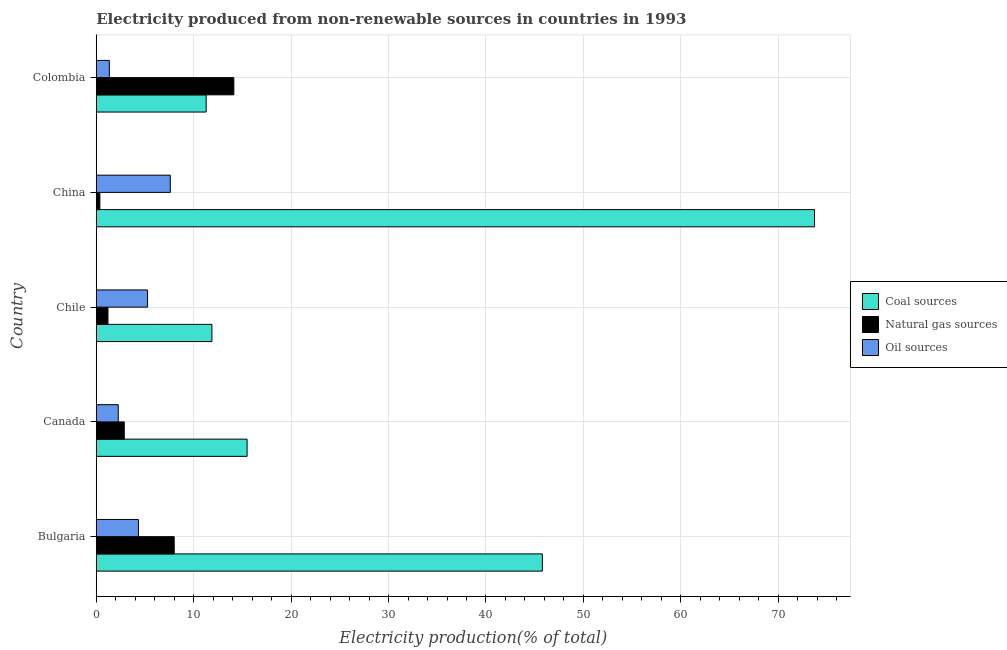How many different coloured bars are there?
Offer a terse response. 3. How many groups of bars are there?
Offer a very short reply. 5. Are the number of bars per tick equal to the number of legend labels?
Keep it short and to the point. Yes. What is the label of the 3rd group of bars from the top?
Give a very brief answer. Chile. What is the percentage of electricity produced by natural gas in Bulgaria?
Your answer should be very brief. 8. Across all countries, what is the maximum percentage of electricity produced by natural gas?
Your answer should be compact. 14.12. Across all countries, what is the minimum percentage of electricity produced by oil sources?
Provide a short and direct response. 1.34. In which country was the percentage of electricity produced by natural gas maximum?
Offer a very short reply. Colombia. In which country was the percentage of electricity produced by coal minimum?
Your answer should be compact. Colombia. What is the total percentage of electricity produced by coal in the graph?
Provide a short and direct response. 158.15. What is the difference between the percentage of electricity produced by natural gas in Canada and that in China?
Provide a short and direct response. 2.5. What is the difference between the percentage of electricity produced by natural gas in Canada and the percentage of electricity produced by oil sources in Chile?
Offer a very short reply. -2.39. What is the average percentage of electricity produced by natural gas per country?
Keep it short and to the point. 5.31. What is the difference between the percentage of electricity produced by coal and percentage of electricity produced by natural gas in China?
Provide a succinct answer. 73.35. What is the ratio of the percentage of electricity produced by coal in Canada to that in China?
Give a very brief answer. 0.21. Is the percentage of electricity produced by natural gas in Chile less than that in China?
Make the answer very short. No. What is the difference between the highest and the second highest percentage of electricity produced by natural gas?
Make the answer very short. 6.12. What is the difference between the highest and the lowest percentage of electricity produced by coal?
Keep it short and to the point. 62.44. In how many countries, is the percentage of electricity produced by coal greater than the average percentage of electricity produced by coal taken over all countries?
Ensure brevity in your answer.  2. What does the 1st bar from the top in Bulgaria represents?
Offer a terse response. Oil sources. What does the 1st bar from the bottom in Colombia represents?
Provide a succinct answer. Coal sources. Is it the case that in every country, the sum of the percentage of electricity produced by coal and percentage of electricity produced by natural gas is greater than the percentage of electricity produced by oil sources?
Provide a succinct answer. Yes. Where does the legend appear in the graph?
Keep it short and to the point. Center right. How many legend labels are there?
Offer a very short reply. 3. How are the legend labels stacked?
Provide a short and direct response. Vertical. What is the title of the graph?
Make the answer very short. Electricity produced from non-renewable sources in countries in 1993. Does "Taxes on income" appear as one of the legend labels in the graph?
Offer a very short reply. No. What is the Electricity production(% of total) of Coal sources in Bulgaria?
Your response must be concise. 45.79. What is the Electricity production(% of total) of Natural gas sources in Bulgaria?
Provide a short and direct response. 8. What is the Electricity production(% of total) of Oil sources in Bulgaria?
Make the answer very short. 4.33. What is the Electricity production(% of total) in Coal sources in Canada?
Ensure brevity in your answer.  15.48. What is the Electricity production(% of total) of Natural gas sources in Canada?
Offer a very short reply. 2.88. What is the Electricity production(% of total) of Oil sources in Canada?
Offer a very short reply. 2.26. What is the Electricity production(% of total) of Coal sources in Chile?
Offer a very short reply. 11.87. What is the Electricity production(% of total) in Natural gas sources in Chile?
Keep it short and to the point. 1.2. What is the Electricity production(% of total) of Oil sources in Chile?
Your answer should be very brief. 5.27. What is the Electricity production(% of total) in Coal sources in China?
Keep it short and to the point. 73.73. What is the Electricity production(% of total) in Natural gas sources in China?
Offer a terse response. 0.37. What is the Electricity production(% of total) in Oil sources in China?
Provide a short and direct response. 7.6. What is the Electricity production(% of total) in Coal sources in Colombia?
Offer a terse response. 11.28. What is the Electricity production(% of total) in Natural gas sources in Colombia?
Provide a short and direct response. 14.12. What is the Electricity production(% of total) of Oil sources in Colombia?
Give a very brief answer. 1.34. Across all countries, what is the maximum Electricity production(% of total) of Coal sources?
Your answer should be very brief. 73.73. Across all countries, what is the maximum Electricity production(% of total) in Natural gas sources?
Your answer should be very brief. 14.12. Across all countries, what is the maximum Electricity production(% of total) of Oil sources?
Your response must be concise. 7.6. Across all countries, what is the minimum Electricity production(% of total) of Coal sources?
Ensure brevity in your answer.  11.28. Across all countries, what is the minimum Electricity production(% of total) in Natural gas sources?
Give a very brief answer. 0.37. Across all countries, what is the minimum Electricity production(% of total) in Oil sources?
Give a very brief answer. 1.34. What is the total Electricity production(% of total) of Coal sources in the graph?
Your answer should be very brief. 158.15. What is the total Electricity production(% of total) of Natural gas sources in the graph?
Your response must be concise. 26.57. What is the total Electricity production(% of total) in Oil sources in the graph?
Offer a terse response. 20.79. What is the difference between the Electricity production(% of total) in Coal sources in Bulgaria and that in Canada?
Your answer should be very brief. 30.31. What is the difference between the Electricity production(% of total) in Natural gas sources in Bulgaria and that in Canada?
Provide a short and direct response. 5.13. What is the difference between the Electricity production(% of total) of Oil sources in Bulgaria and that in Canada?
Your response must be concise. 2.07. What is the difference between the Electricity production(% of total) in Coal sources in Bulgaria and that in Chile?
Give a very brief answer. 33.92. What is the difference between the Electricity production(% of total) in Natural gas sources in Bulgaria and that in Chile?
Your answer should be compact. 6.8. What is the difference between the Electricity production(% of total) of Oil sources in Bulgaria and that in Chile?
Give a very brief answer. -0.94. What is the difference between the Electricity production(% of total) of Coal sources in Bulgaria and that in China?
Your answer should be very brief. -27.94. What is the difference between the Electricity production(% of total) in Natural gas sources in Bulgaria and that in China?
Offer a terse response. 7.63. What is the difference between the Electricity production(% of total) in Oil sources in Bulgaria and that in China?
Provide a succinct answer. -3.27. What is the difference between the Electricity production(% of total) in Coal sources in Bulgaria and that in Colombia?
Provide a succinct answer. 34.51. What is the difference between the Electricity production(% of total) in Natural gas sources in Bulgaria and that in Colombia?
Provide a short and direct response. -6.12. What is the difference between the Electricity production(% of total) in Oil sources in Bulgaria and that in Colombia?
Offer a terse response. 2.98. What is the difference between the Electricity production(% of total) in Coal sources in Canada and that in Chile?
Make the answer very short. 3.61. What is the difference between the Electricity production(% of total) in Natural gas sources in Canada and that in Chile?
Your answer should be compact. 1.68. What is the difference between the Electricity production(% of total) in Oil sources in Canada and that in Chile?
Offer a terse response. -3.01. What is the difference between the Electricity production(% of total) of Coal sources in Canada and that in China?
Make the answer very short. -58.24. What is the difference between the Electricity production(% of total) of Natural gas sources in Canada and that in China?
Your answer should be very brief. 2.5. What is the difference between the Electricity production(% of total) of Oil sources in Canada and that in China?
Your answer should be compact. -5.34. What is the difference between the Electricity production(% of total) in Coal sources in Canada and that in Colombia?
Your answer should be compact. 4.2. What is the difference between the Electricity production(% of total) in Natural gas sources in Canada and that in Colombia?
Your answer should be very brief. -11.25. What is the difference between the Electricity production(% of total) of Oil sources in Canada and that in Colombia?
Keep it short and to the point. 0.91. What is the difference between the Electricity production(% of total) in Coal sources in Chile and that in China?
Provide a succinct answer. -61.86. What is the difference between the Electricity production(% of total) of Natural gas sources in Chile and that in China?
Give a very brief answer. 0.83. What is the difference between the Electricity production(% of total) in Oil sources in Chile and that in China?
Offer a terse response. -2.33. What is the difference between the Electricity production(% of total) of Coal sources in Chile and that in Colombia?
Keep it short and to the point. 0.59. What is the difference between the Electricity production(% of total) in Natural gas sources in Chile and that in Colombia?
Keep it short and to the point. -12.92. What is the difference between the Electricity production(% of total) of Oil sources in Chile and that in Colombia?
Offer a very short reply. 3.92. What is the difference between the Electricity production(% of total) in Coal sources in China and that in Colombia?
Your response must be concise. 62.44. What is the difference between the Electricity production(% of total) in Natural gas sources in China and that in Colombia?
Your answer should be compact. -13.75. What is the difference between the Electricity production(% of total) in Oil sources in China and that in Colombia?
Your response must be concise. 6.25. What is the difference between the Electricity production(% of total) in Coal sources in Bulgaria and the Electricity production(% of total) in Natural gas sources in Canada?
Your answer should be compact. 42.91. What is the difference between the Electricity production(% of total) in Coal sources in Bulgaria and the Electricity production(% of total) in Oil sources in Canada?
Provide a succinct answer. 43.53. What is the difference between the Electricity production(% of total) in Natural gas sources in Bulgaria and the Electricity production(% of total) in Oil sources in Canada?
Keep it short and to the point. 5.74. What is the difference between the Electricity production(% of total) of Coal sources in Bulgaria and the Electricity production(% of total) of Natural gas sources in Chile?
Give a very brief answer. 44.59. What is the difference between the Electricity production(% of total) of Coal sources in Bulgaria and the Electricity production(% of total) of Oil sources in Chile?
Make the answer very short. 40.52. What is the difference between the Electricity production(% of total) of Natural gas sources in Bulgaria and the Electricity production(% of total) of Oil sources in Chile?
Offer a very short reply. 2.73. What is the difference between the Electricity production(% of total) in Coal sources in Bulgaria and the Electricity production(% of total) in Natural gas sources in China?
Offer a very short reply. 45.42. What is the difference between the Electricity production(% of total) in Coal sources in Bulgaria and the Electricity production(% of total) in Oil sources in China?
Give a very brief answer. 38.19. What is the difference between the Electricity production(% of total) of Natural gas sources in Bulgaria and the Electricity production(% of total) of Oil sources in China?
Offer a terse response. 0.4. What is the difference between the Electricity production(% of total) of Coal sources in Bulgaria and the Electricity production(% of total) of Natural gas sources in Colombia?
Ensure brevity in your answer.  31.67. What is the difference between the Electricity production(% of total) of Coal sources in Bulgaria and the Electricity production(% of total) of Oil sources in Colombia?
Give a very brief answer. 44.44. What is the difference between the Electricity production(% of total) of Natural gas sources in Bulgaria and the Electricity production(% of total) of Oil sources in Colombia?
Keep it short and to the point. 6.66. What is the difference between the Electricity production(% of total) of Coal sources in Canada and the Electricity production(% of total) of Natural gas sources in Chile?
Make the answer very short. 14.28. What is the difference between the Electricity production(% of total) of Coal sources in Canada and the Electricity production(% of total) of Oil sources in Chile?
Your response must be concise. 10.22. What is the difference between the Electricity production(% of total) in Natural gas sources in Canada and the Electricity production(% of total) in Oil sources in Chile?
Keep it short and to the point. -2.39. What is the difference between the Electricity production(% of total) in Coal sources in Canada and the Electricity production(% of total) in Natural gas sources in China?
Your response must be concise. 15.11. What is the difference between the Electricity production(% of total) of Coal sources in Canada and the Electricity production(% of total) of Oil sources in China?
Your response must be concise. 7.88. What is the difference between the Electricity production(% of total) of Natural gas sources in Canada and the Electricity production(% of total) of Oil sources in China?
Provide a short and direct response. -4.72. What is the difference between the Electricity production(% of total) of Coal sources in Canada and the Electricity production(% of total) of Natural gas sources in Colombia?
Provide a short and direct response. 1.36. What is the difference between the Electricity production(% of total) of Coal sources in Canada and the Electricity production(% of total) of Oil sources in Colombia?
Offer a terse response. 14.14. What is the difference between the Electricity production(% of total) of Natural gas sources in Canada and the Electricity production(% of total) of Oil sources in Colombia?
Provide a short and direct response. 1.53. What is the difference between the Electricity production(% of total) in Coal sources in Chile and the Electricity production(% of total) in Natural gas sources in China?
Provide a succinct answer. 11.5. What is the difference between the Electricity production(% of total) of Coal sources in Chile and the Electricity production(% of total) of Oil sources in China?
Your response must be concise. 4.27. What is the difference between the Electricity production(% of total) of Natural gas sources in Chile and the Electricity production(% of total) of Oil sources in China?
Your answer should be very brief. -6.4. What is the difference between the Electricity production(% of total) of Coal sources in Chile and the Electricity production(% of total) of Natural gas sources in Colombia?
Keep it short and to the point. -2.25. What is the difference between the Electricity production(% of total) in Coal sources in Chile and the Electricity production(% of total) in Oil sources in Colombia?
Provide a short and direct response. 10.53. What is the difference between the Electricity production(% of total) of Natural gas sources in Chile and the Electricity production(% of total) of Oil sources in Colombia?
Make the answer very short. -0.14. What is the difference between the Electricity production(% of total) in Coal sources in China and the Electricity production(% of total) in Natural gas sources in Colombia?
Keep it short and to the point. 59.6. What is the difference between the Electricity production(% of total) of Coal sources in China and the Electricity production(% of total) of Oil sources in Colombia?
Provide a succinct answer. 72.38. What is the difference between the Electricity production(% of total) of Natural gas sources in China and the Electricity production(% of total) of Oil sources in Colombia?
Make the answer very short. -0.97. What is the average Electricity production(% of total) in Coal sources per country?
Your answer should be compact. 31.63. What is the average Electricity production(% of total) in Natural gas sources per country?
Your answer should be compact. 5.31. What is the average Electricity production(% of total) of Oil sources per country?
Offer a terse response. 4.16. What is the difference between the Electricity production(% of total) of Coal sources and Electricity production(% of total) of Natural gas sources in Bulgaria?
Provide a short and direct response. 37.79. What is the difference between the Electricity production(% of total) of Coal sources and Electricity production(% of total) of Oil sources in Bulgaria?
Give a very brief answer. 41.46. What is the difference between the Electricity production(% of total) of Natural gas sources and Electricity production(% of total) of Oil sources in Bulgaria?
Your answer should be very brief. 3.67. What is the difference between the Electricity production(% of total) of Coal sources and Electricity production(% of total) of Natural gas sources in Canada?
Provide a short and direct response. 12.61. What is the difference between the Electricity production(% of total) in Coal sources and Electricity production(% of total) in Oil sources in Canada?
Provide a succinct answer. 13.23. What is the difference between the Electricity production(% of total) of Natural gas sources and Electricity production(% of total) of Oil sources in Canada?
Provide a short and direct response. 0.62. What is the difference between the Electricity production(% of total) of Coal sources and Electricity production(% of total) of Natural gas sources in Chile?
Your answer should be very brief. 10.67. What is the difference between the Electricity production(% of total) of Coal sources and Electricity production(% of total) of Oil sources in Chile?
Your response must be concise. 6.6. What is the difference between the Electricity production(% of total) in Natural gas sources and Electricity production(% of total) in Oil sources in Chile?
Your answer should be compact. -4.07. What is the difference between the Electricity production(% of total) of Coal sources and Electricity production(% of total) of Natural gas sources in China?
Your answer should be compact. 73.35. What is the difference between the Electricity production(% of total) of Coal sources and Electricity production(% of total) of Oil sources in China?
Make the answer very short. 66.13. What is the difference between the Electricity production(% of total) in Natural gas sources and Electricity production(% of total) in Oil sources in China?
Give a very brief answer. -7.23. What is the difference between the Electricity production(% of total) in Coal sources and Electricity production(% of total) in Natural gas sources in Colombia?
Your response must be concise. -2.84. What is the difference between the Electricity production(% of total) of Coal sources and Electricity production(% of total) of Oil sources in Colombia?
Keep it short and to the point. 9.94. What is the difference between the Electricity production(% of total) in Natural gas sources and Electricity production(% of total) in Oil sources in Colombia?
Offer a terse response. 12.78. What is the ratio of the Electricity production(% of total) in Coal sources in Bulgaria to that in Canada?
Provide a succinct answer. 2.96. What is the ratio of the Electricity production(% of total) of Natural gas sources in Bulgaria to that in Canada?
Make the answer very short. 2.78. What is the ratio of the Electricity production(% of total) of Oil sources in Bulgaria to that in Canada?
Your response must be concise. 1.92. What is the ratio of the Electricity production(% of total) in Coal sources in Bulgaria to that in Chile?
Your response must be concise. 3.86. What is the ratio of the Electricity production(% of total) in Natural gas sources in Bulgaria to that in Chile?
Make the answer very short. 6.67. What is the ratio of the Electricity production(% of total) of Oil sources in Bulgaria to that in Chile?
Make the answer very short. 0.82. What is the ratio of the Electricity production(% of total) of Coal sources in Bulgaria to that in China?
Ensure brevity in your answer.  0.62. What is the ratio of the Electricity production(% of total) of Natural gas sources in Bulgaria to that in China?
Your answer should be very brief. 21.53. What is the ratio of the Electricity production(% of total) of Oil sources in Bulgaria to that in China?
Your response must be concise. 0.57. What is the ratio of the Electricity production(% of total) in Coal sources in Bulgaria to that in Colombia?
Your answer should be compact. 4.06. What is the ratio of the Electricity production(% of total) of Natural gas sources in Bulgaria to that in Colombia?
Give a very brief answer. 0.57. What is the ratio of the Electricity production(% of total) of Oil sources in Bulgaria to that in Colombia?
Give a very brief answer. 3.22. What is the ratio of the Electricity production(% of total) of Coal sources in Canada to that in Chile?
Offer a very short reply. 1.3. What is the ratio of the Electricity production(% of total) in Natural gas sources in Canada to that in Chile?
Provide a short and direct response. 2.4. What is the ratio of the Electricity production(% of total) in Oil sources in Canada to that in Chile?
Provide a short and direct response. 0.43. What is the ratio of the Electricity production(% of total) of Coal sources in Canada to that in China?
Your response must be concise. 0.21. What is the ratio of the Electricity production(% of total) in Natural gas sources in Canada to that in China?
Make the answer very short. 7.74. What is the ratio of the Electricity production(% of total) of Oil sources in Canada to that in China?
Make the answer very short. 0.3. What is the ratio of the Electricity production(% of total) in Coal sources in Canada to that in Colombia?
Your response must be concise. 1.37. What is the ratio of the Electricity production(% of total) in Natural gas sources in Canada to that in Colombia?
Make the answer very short. 0.2. What is the ratio of the Electricity production(% of total) of Oil sources in Canada to that in Colombia?
Your answer should be very brief. 1.68. What is the ratio of the Electricity production(% of total) of Coal sources in Chile to that in China?
Give a very brief answer. 0.16. What is the ratio of the Electricity production(% of total) of Natural gas sources in Chile to that in China?
Keep it short and to the point. 3.23. What is the ratio of the Electricity production(% of total) in Oil sources in Chile to that in China?
Your answer should be compact. 0.69. What is the ratio of the Electricity production(% of total) of Coal sources in Chile to that in Colombia?
Offer a very short reply. 1.05. What is the ratio of the Electricity production(% of total) of Natural gas sources in Chile to that in Colombia?
Offer a very short reply. 0.09. What is the ratio of the Electricity production(% of total) of Oil sources in Chile to that in Colombia?
Provide a succinct answer. 3.92. What is the ratio of the Electricity production(% of total) in Coal sources in China to that in Colombia?
Ensure brevity in your answer.  6.54. What is the ratio of the Electricity production(% of total) of Natural gas sources in China to that in Colombia?
Provide a short and direct response. 0.03. What is the ratio of the Electricity production(% of total) of Oil sources in China to that in Colombia?
Offer a very short reply. 5.66. What is the difference between the highest and the second highest Electricity production(% of total) in Coal sources?
Your response must be concise. 27.94. What is the difference between the highest and the second highest Electricity production(% of total) of Natural gas sources?
Keep it short and to the point. 6.12. What is the difference between the highest and the second highest Electricity production(% of total) of Oil sources?
Keep it short and to the point. 2.33. What is the difference between the highest and the lowest Electricity production(% of total) of Coal sources?
Your answer should be very brief. 62.44. What is the difference between the highest and the lowest Electricity production(% of total) in Natural gas sources?
Keep it short and to the point. 13.75. What is the difference between the highest and the lowest Electricity production(% of total) in Oil sources?
Offer a terse response. 6.25. 